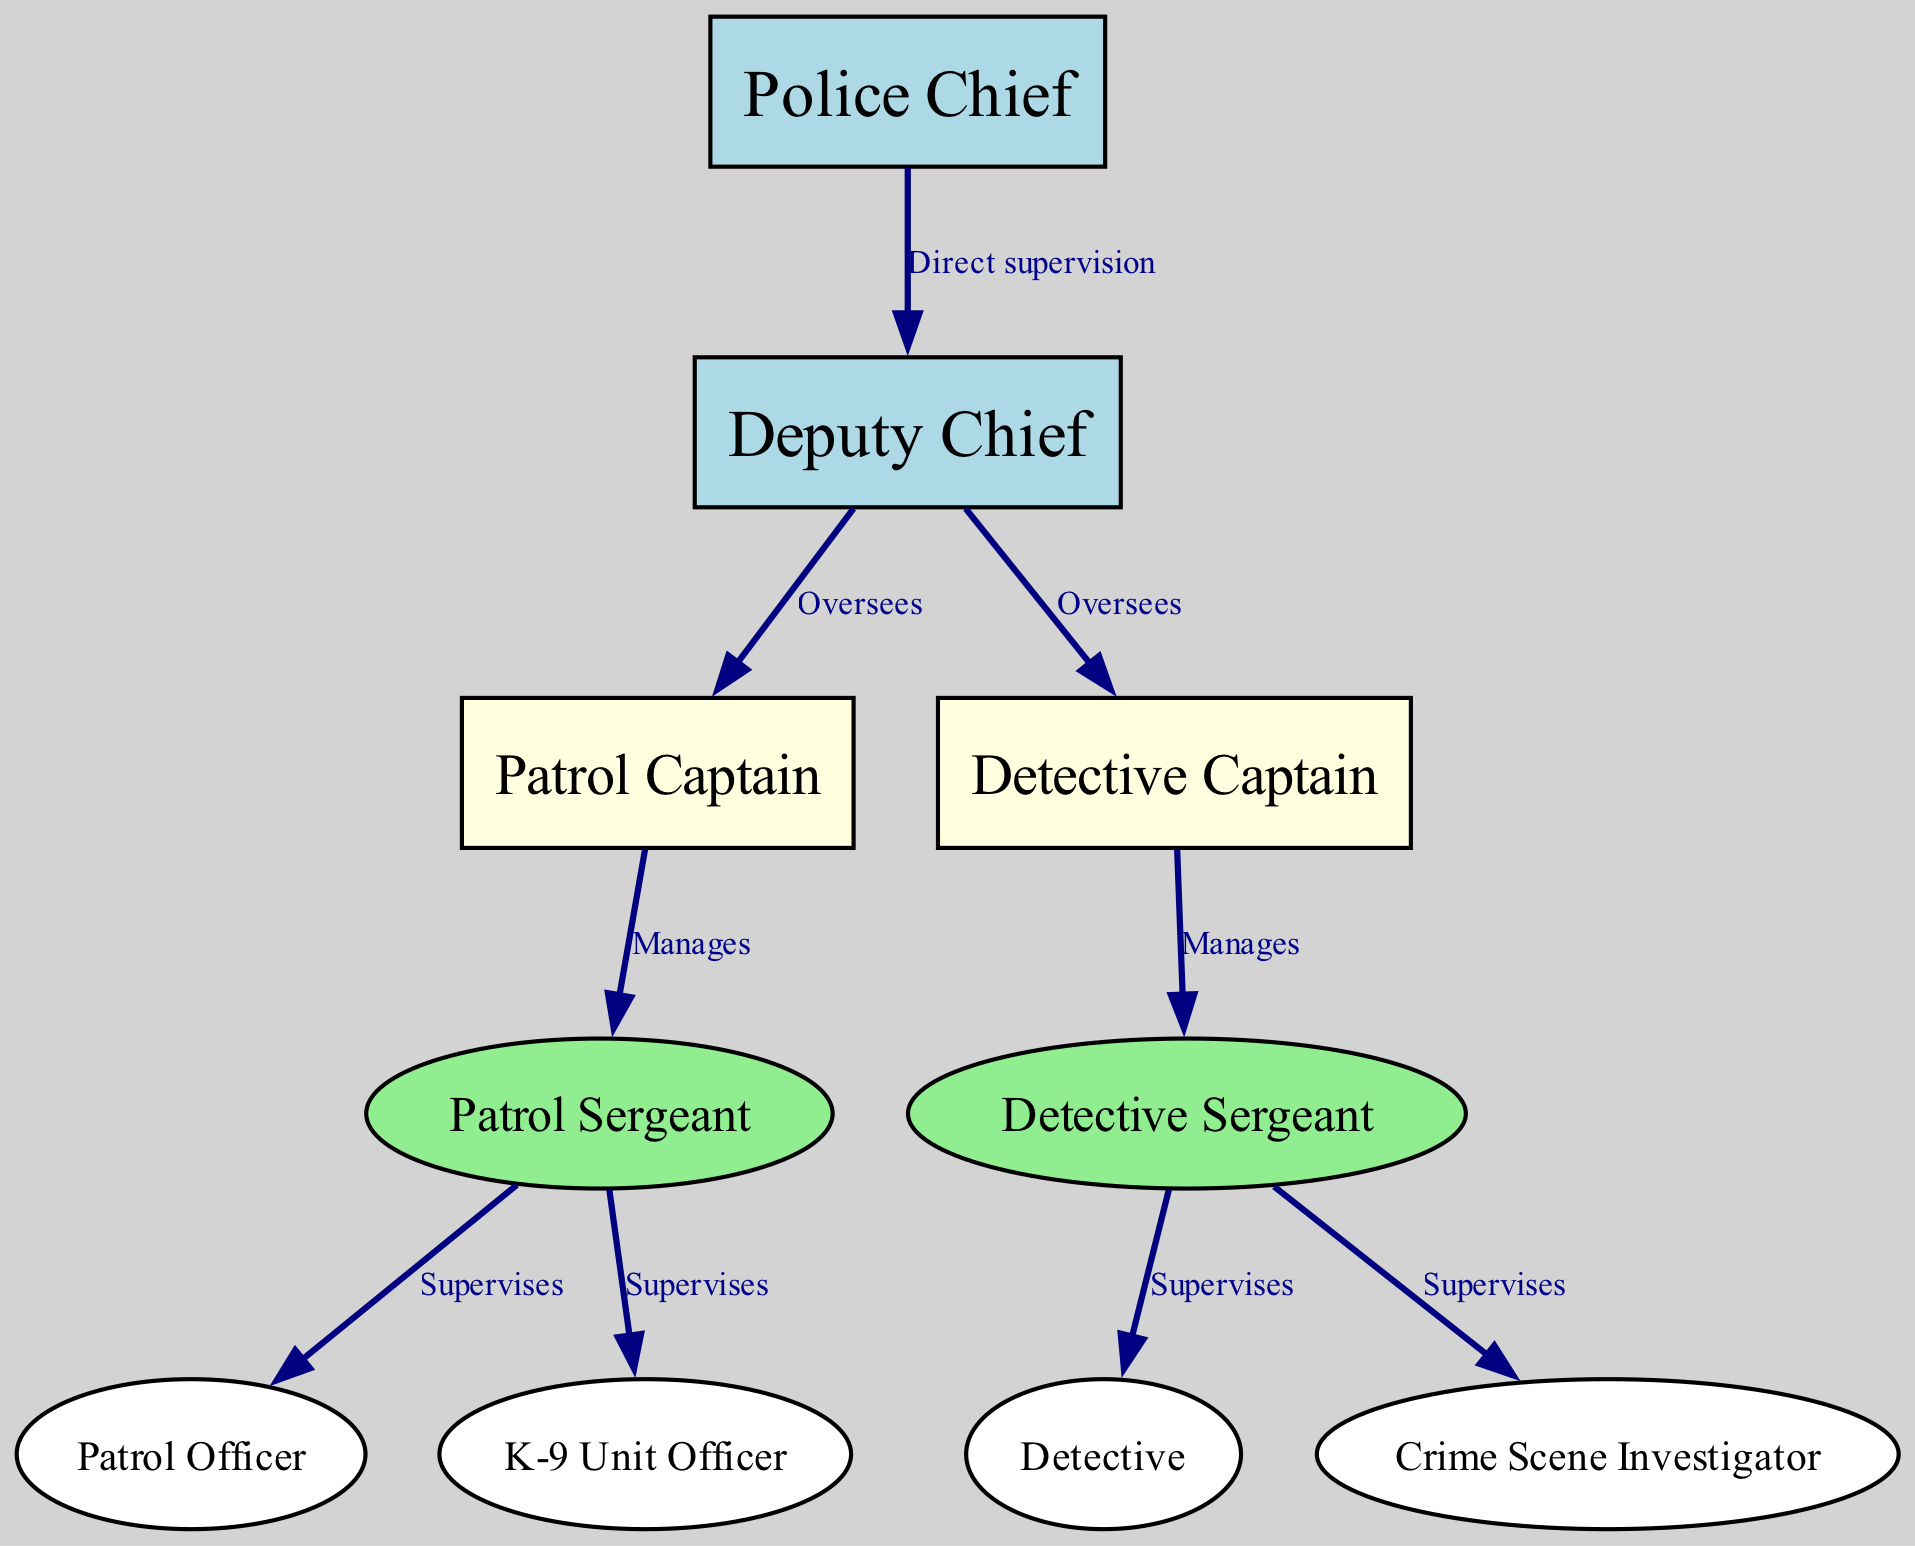What is the highest position in the chain of command? The diagram displays the "Police Chief" at the top of the hierarchy, which signifies the highest authority in the police department.
Answer: Police Chief How many nodes are present in the diagram? By counting the unique roles in the diagram, we see there are a total of 10 nodes representing different positions.
Answer: 10 Which role directly supervises the Patrol Captain? The diagram indicates that the "Deputy Chief" directly supervises the "Patrol Captain" as it is the edge connecting these two nodes.
Answer: Deputy Chief Who manages the Detective Sergeant? Reviewing the diagram, the "Detective Captain" has a direct edge to the "Detective Sergeant" indicating that he is the manager of that position.
Answer: Detective Captain How many roles does the Patrol Sergeant supervise? The diagram shows two direct edges originating from the "Patrol Sergeant" to "Patrol Officer" and "K-9 Unit Officer", indicating he supervises both those positions.
Answer: 2 What type of relationship is represented between the Police Chief and the Deputy Chief? The edge between these nodes is labeled "Direct supervision", illustrating the hierarchical relationship where the Police Chief directly supervises the Deputy Chief.
Answer: Direct supervision Which unit officer does the Detective Sergeant supervise? According to the diagram, the "Detective Sergeant" supervises "Detective" and "Crime Scene Investigator", and both are directly linked to him.
Answer: Detective, Crime Scene Investigator What color represents the Patrol Captain in the diagram? The diagram uses light yellow to represent the "Patrol Captain", which is a color defined for that node type.
Answer: Light yellow Is the K-9 Unit Officer under direct supervision or managed by someone? The diagram indicates that the "K-9 Unit Officer" is supervised by the "Patrol Sergeant", showing that it falls under his purview rather than being directly managed.
Answer: Supervised What is the position that oversees both the Patrol Captain and Detective Captain? By inspecting the diagram, the "Deputy Chief" has edges connecting to both "Patrol Captain" and "Detective Captain", confirming that this role oversees both.
Answer: Deputy Chief 